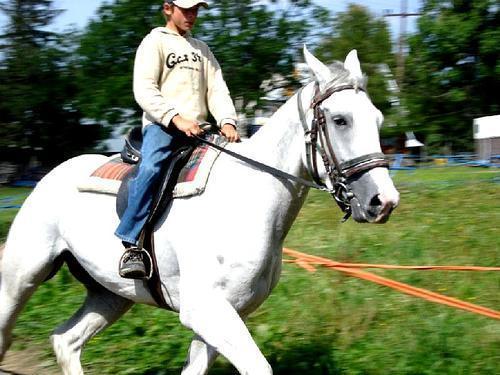Does the caption "The horse is beneath the person." correctly depict the image?
Answer yes or no. Yes. 